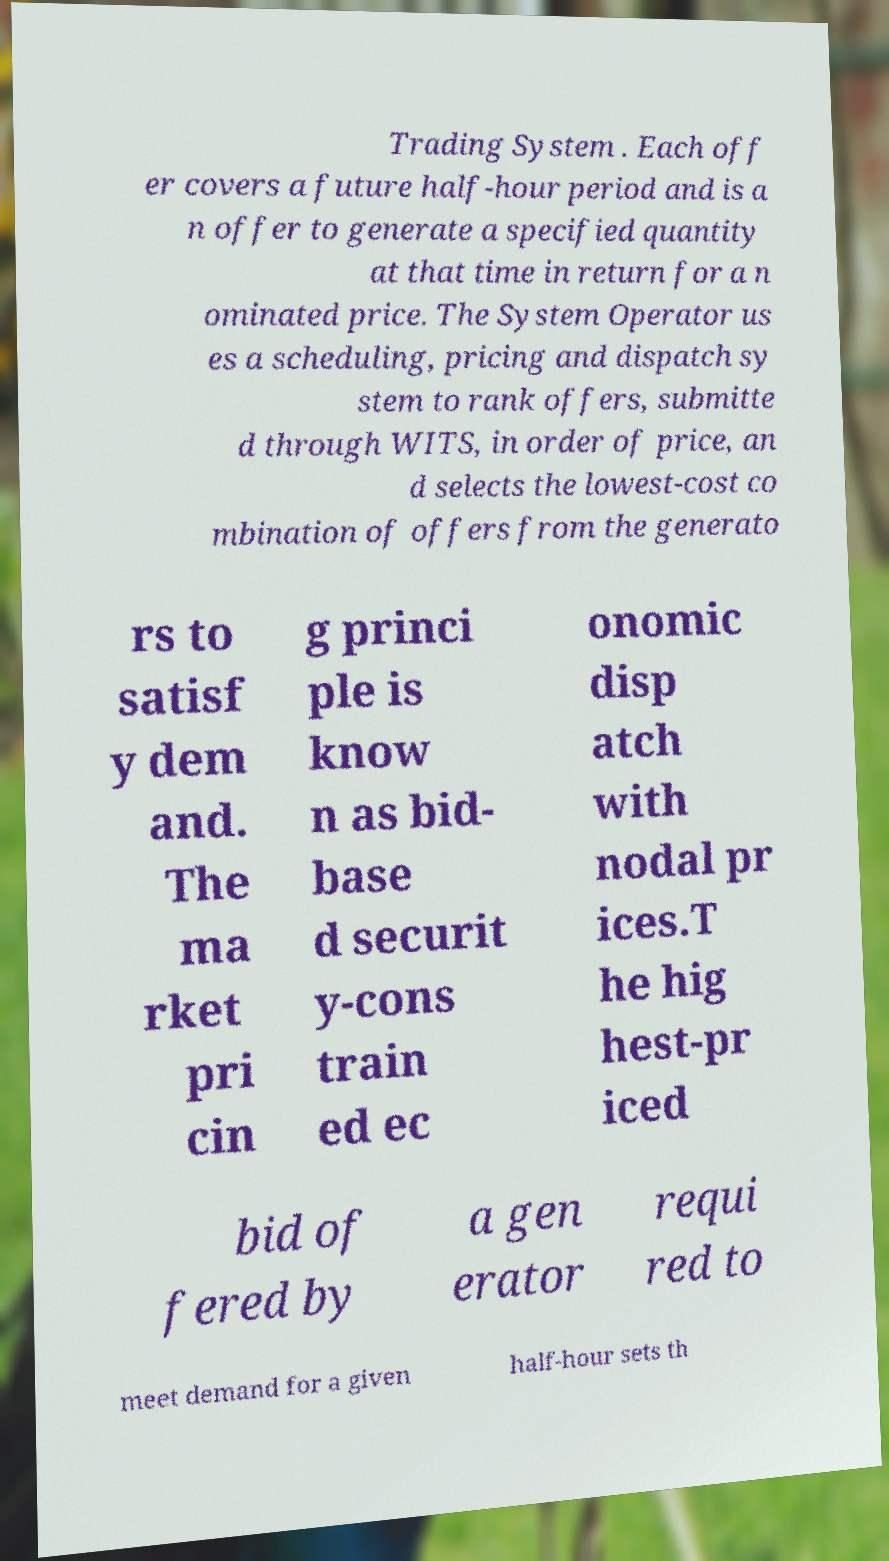Can you read and provide the text displayed in the image?This photo seems to have some interesting text. Can you extract and type it out for me? Trading System . Each off er covers a future half-hour period and is a n offer to generate a specified quantity at that time in return for a n ominated price. The System Operator us es a scheduling, pricing and dispatch sy stem to rank offers, submitte d through WITS, in order of price, an d selects the lowest-cost co mbination of offers from the generato rs to satisf y dem and. The ma rket pri cin g princi ple is know n as bid- base d securit y-cons train ed ec onomic disp atch with nodal pr ices.T he hig hest-pr iced bid of fered by a gen erator requi red to meet demand for a given half-hour sets th 